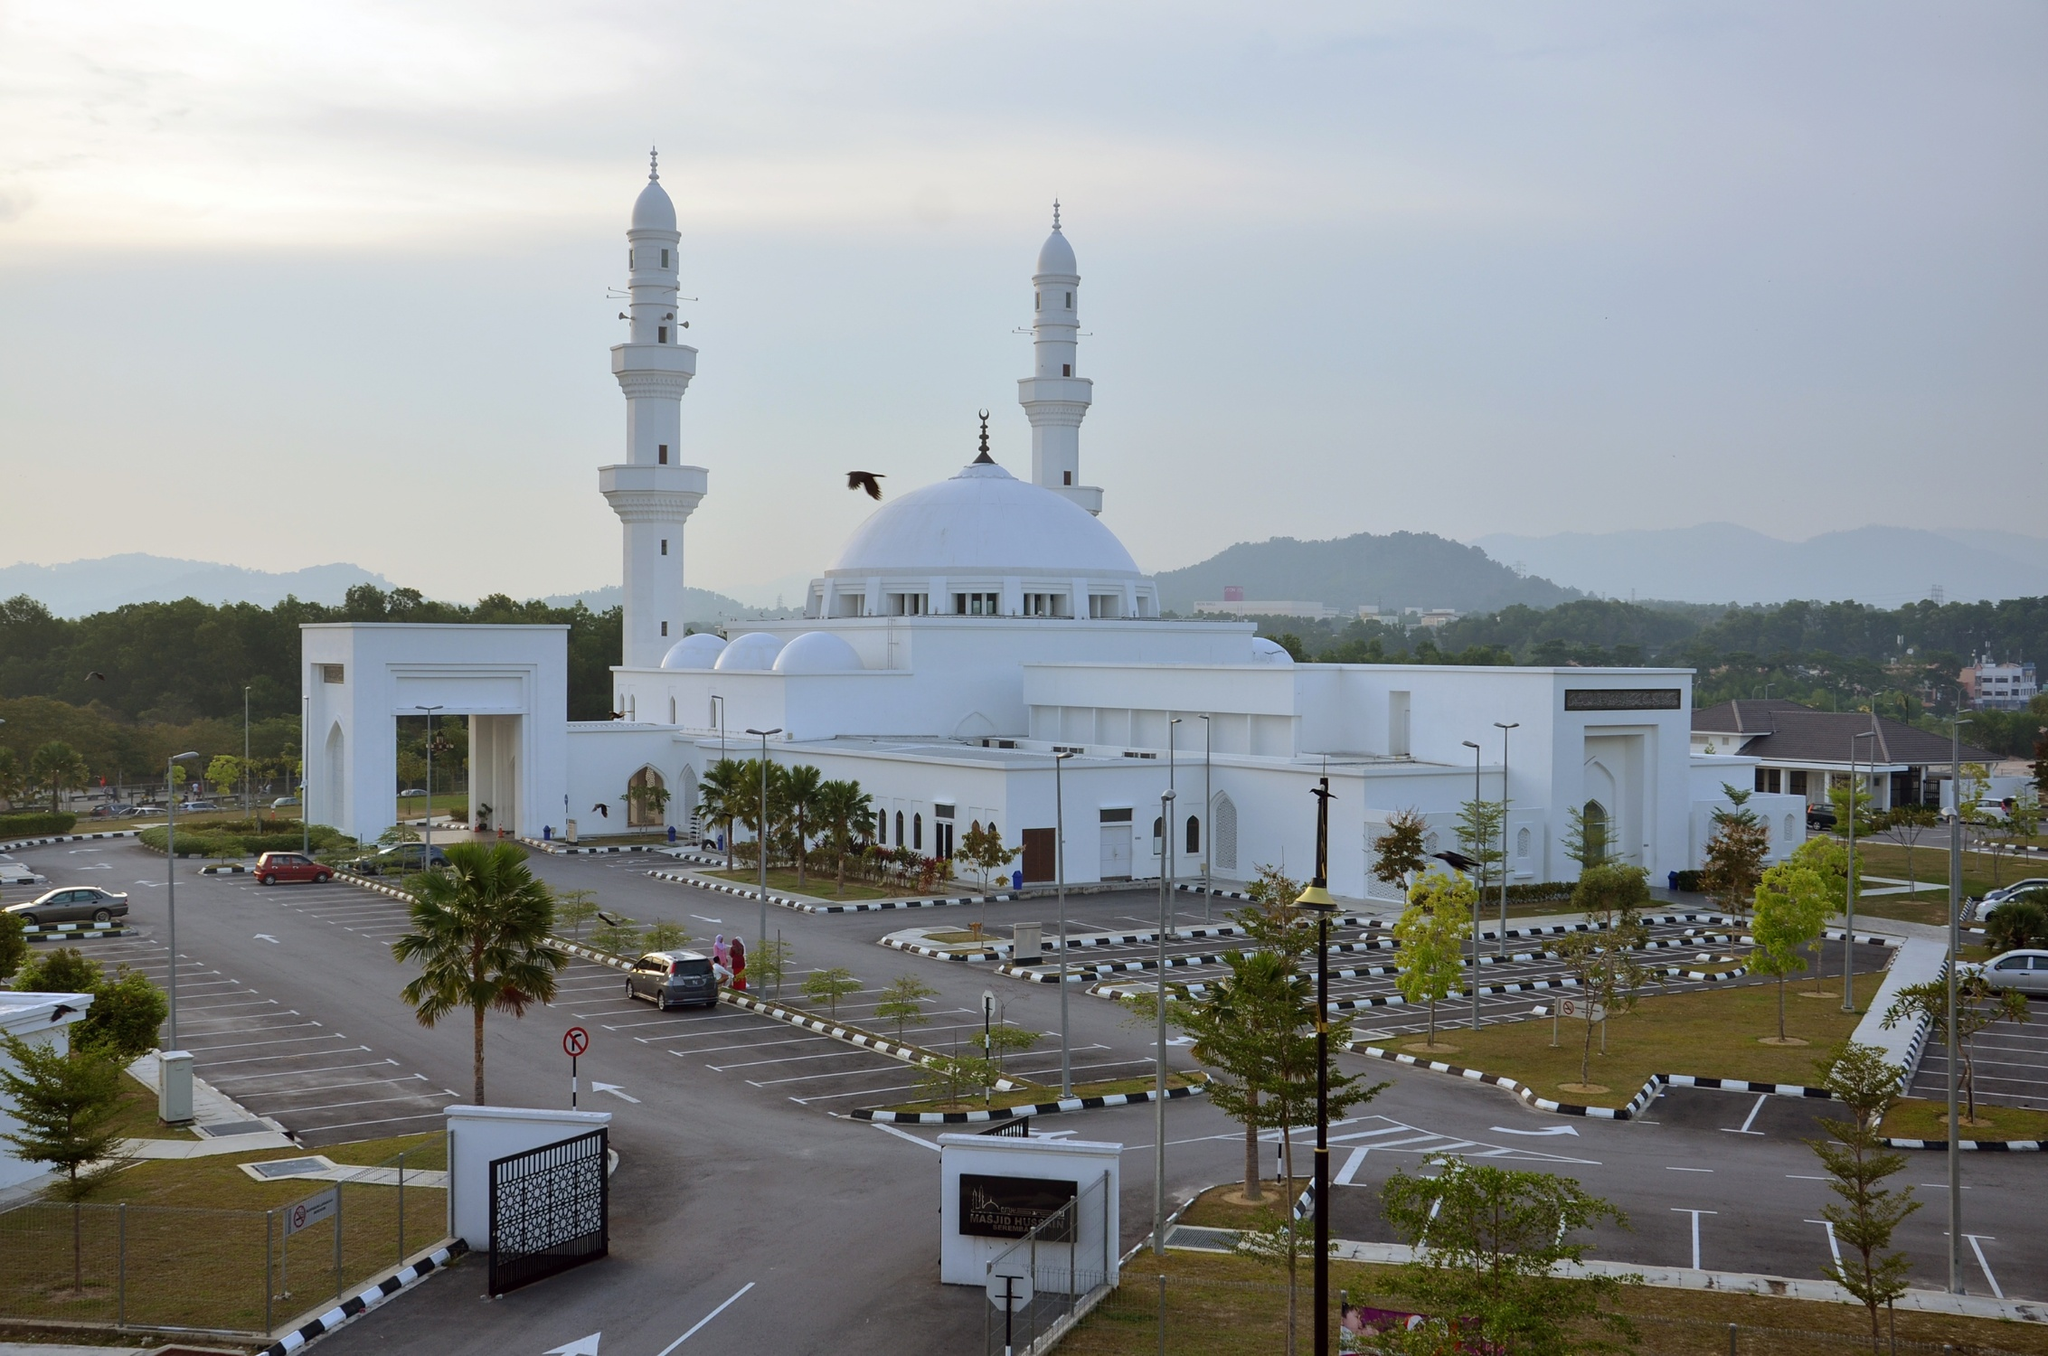What role does this mosque play in the community today? Today, the Tengku Ampuan Jemaah Mosque serves as a vibrant epicenter for spiritual, educational, and social activities within the community. Beyond being a place of worship where daily prayers, Jummah, and Ramadan activities take place, it is also a venue for community gatherings and social events. The mosque plays a significant role in the religious education of the community, providing classes and lectures on Islamic teachings. It acts as a charitable institution, organizing various activities to aid the less fortunate. Moreover, it serves as a cultural hub where the community can come together to celebrate religious holidays, fostering a sense of unity and cultural continuity. Paint a picture of a bustling day during a major religious festival at the mosque. On a bustling day during Eid al-Fitr at the Tengku Ampuan Jemaah Mosque, the scene brims with jubilance and community spirit. The mosque, adorned with festive decorations, welcomes throngs of worshippers dressed in their finest traditional attire. From the early hours of the morning, the air is filled with the fervent recitations of Takbir and community prayers. The spacious parking area and grounds are transformed into vibrant spaces of socialization, where families and friends greet each other with warmth and joy. Children, gleefully running around, add a lively energy to the scene. Stalls lined up outside the mosque offer an array of traditional food and sweets, creating a bursting array of appetizing aromas. The day sees communal feasts, charitable activities, and cultural performances, all reflecting the strong sense of unity and celebration within the community. The mosque stands majestically at the heart of it all, embodying both the spiritual and communal essence of the festival. 